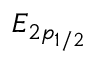<formula> <loc_0><loc_0><loc_500><loc_500>E _ { 2 p _ { 1 / 2 } }</formula> 